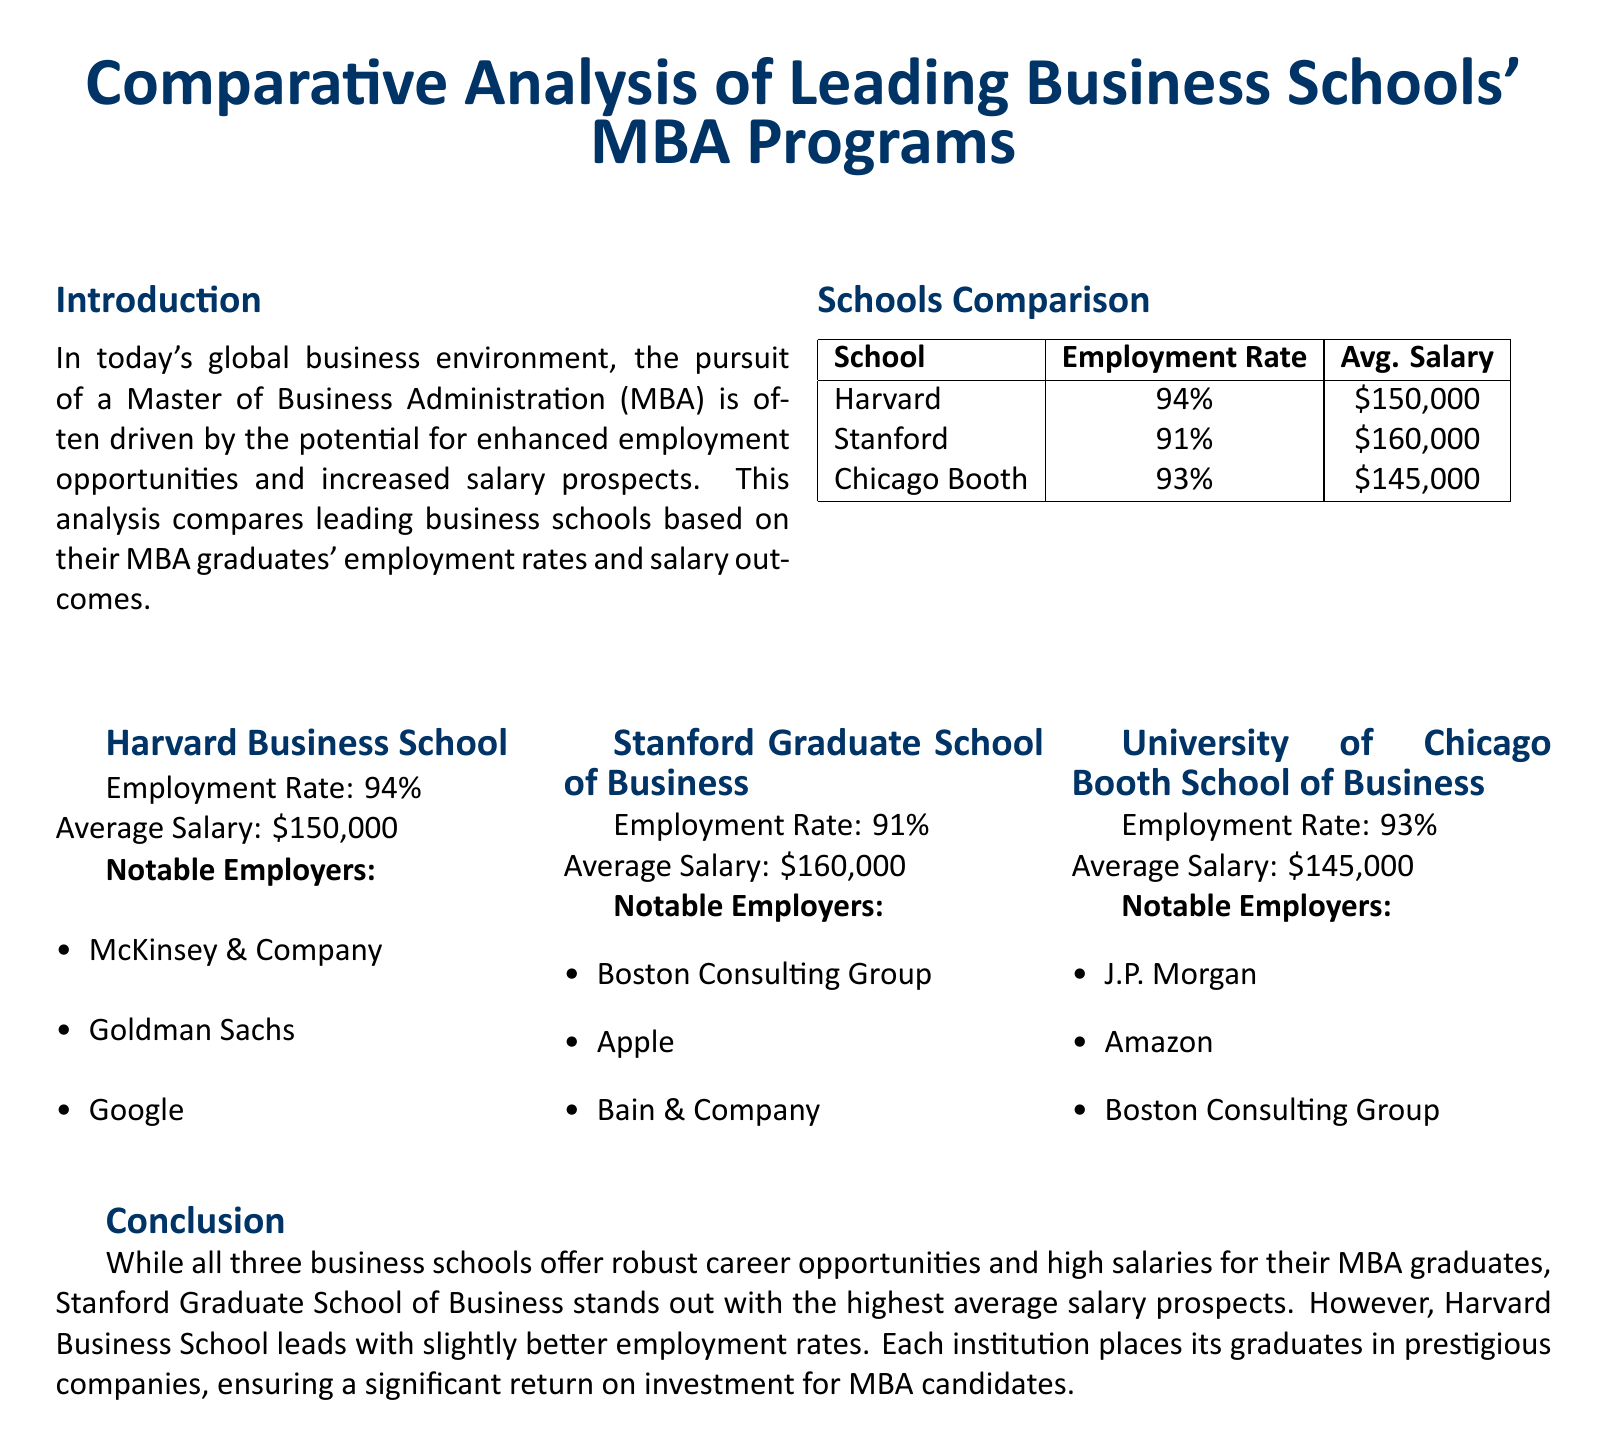What is the employment rate of Harvard Business School? The document states that Harvard Business School has an employment rate of 94%.
Answer: 94% What is the average salary of an MBA graduate from Stanford? The document indicates that the average salary for graduates from Stanford Graduate School of Business is $160,000.
Answer: $160,000 Which business school has the highest average salary? According to the document, Stanford Graduate School of Business has the highest average salary prospects.
Answer: Stanford Graduate School of Business What notable employer is associated with the University of Chicago Booth School of Business? The document lists J.P. Morgan as a notable employer of graduates from the University of Chicago Booth School of Business.
Answer: J.P. Morgan How does Harvard's employment rate compare to Chicago Booth's? The document shows Harvard has a higher employment rate (94%) compared to Chicago Booth (93%), making it clear that Harvard leads in this aspect.
Answer: Higher What percentage of alumni from Stanford Graduate School of Business are employed after graduation? The document states that 91% of Stanford graduates are employed after graduation.
Answer: 91% How many notable employers are listed for each business school? The document lists three notable employers for each of the three business schools.
Answer: Three What is the employment rate difference between Harvard and Chicago Booth? The document indicates that Harvard's employment rate (94%) is 1% higher than Chicago Booth's employment rate (93%).
Answer: 1% Which business school leads in terms of employment rates? The document makes it clear that Harvard Business School leads in employment rates among the schools compared.
Answer: Harvard Business School 